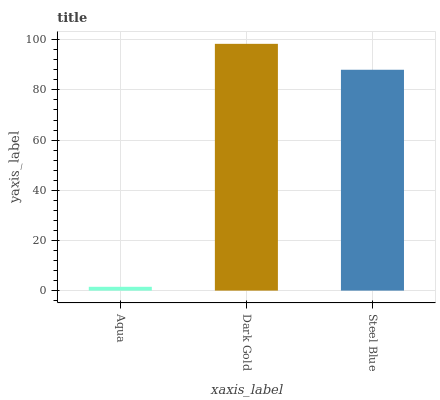Is Aqua the minimum?
Answer yes or no. Yes. Is Dark Gold the maximum?
Answer yes or no. Yes. Is Steel Blue the minimum?
Answer yes or no. No. Is Steel Blue the maximum?
Answer yes or no. No. Is Dark Gold greater than Steel Blue?
Answer yes or no. Yes. Is Steel Blue less than Dark Gold?
Answer yes or no. Yes. Is Steel Blue greater than Dark Gold?
Answer yes or no. No. Is Dark Gold less than Steel Blue?
Answer yes or no. No. Is Steel Blue the high median?
Answer yes or no. Yes. Is Steel Blue the low median?
Answer yes or no. Yes. Is Dark Gold the high median?
Answer yes or no. No. Is Dark Gold the low median?
Answer yes or no. No. 